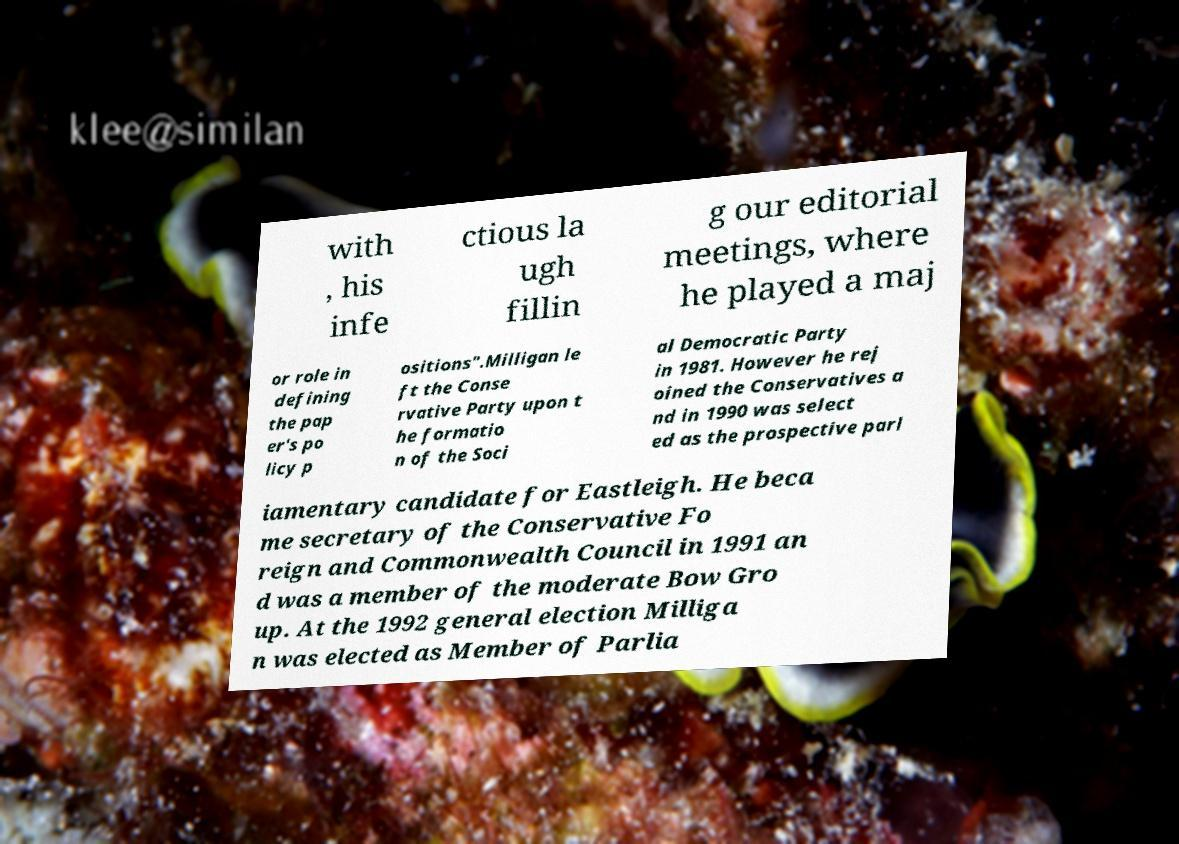Please identify and transcribe the text found in this image. with , his infe ctious la ugh fillin g our editorial meetings, where he played a maj or role in defining the pap er's po licy p ositions".Milligan le ft the Conse rvative Party upon t he formatio n of the Soci al Democratic Party in 1981. However he rej oined the Conservatives a nd in 1990 was select ed as the prospective parl iamentary candidate for Eastleigh. He beca me secretary of the Conservative Fo reign and Commonwealth Council in 1991 an d was a member of the moderate Bow Gro up. At the 1992 general election Milliga n was elected as Member of Parlia 